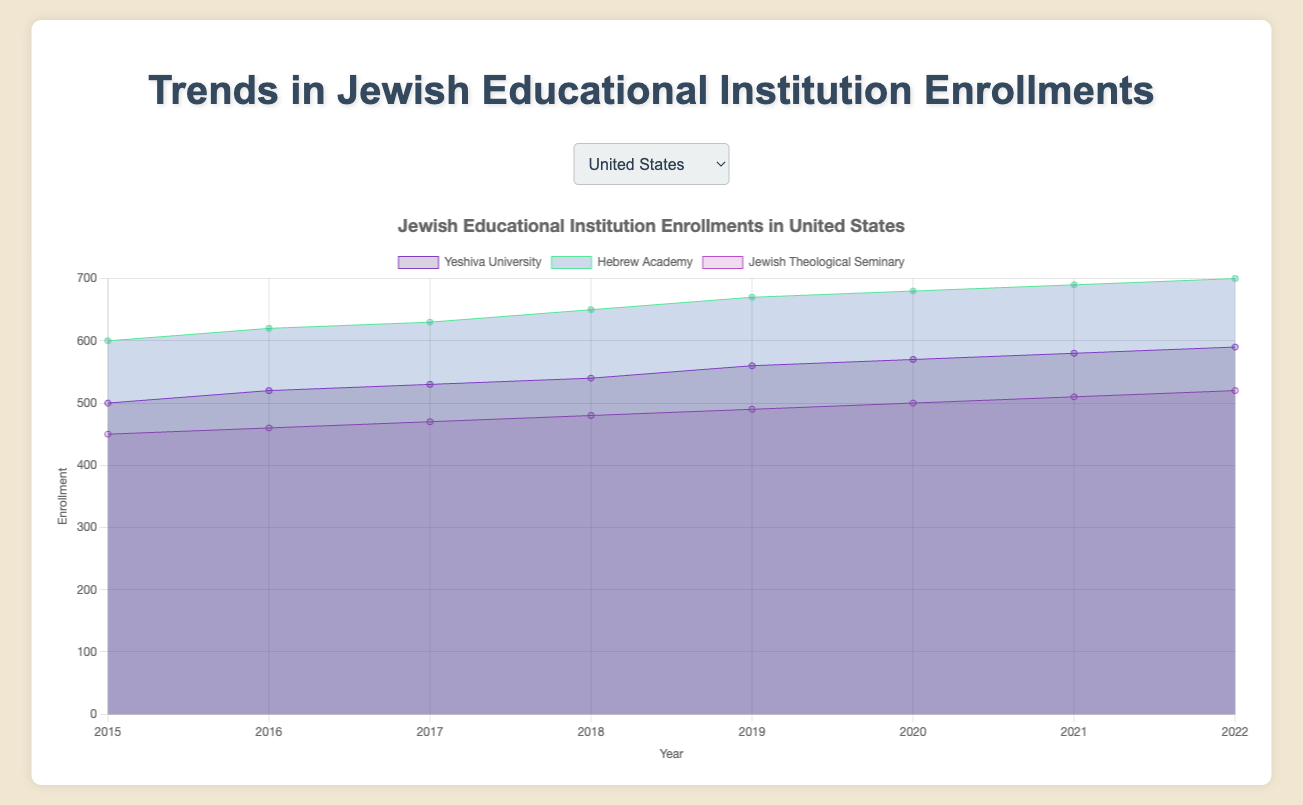Which country has the highest enrollment in 2022 for any single institution? In Israel, Hebrew University of Jerusalem had the highest enrollment in 2022 with 780 students, as shown by the peak on the chart.
Answer: Israel Which institution in the United States had the lowest enrollment in 2015? The Jewish Theological Seminary had the lowest enrollment in 2015 in the United States, with 450 students, according to the chart data.
Answer: Jewish Theological Seminary Compare the enrollment trends for Yeshiva University and Hebrew University of Jerusalem from 2015 to 2022. Which one grew faster? Yeshiva University grew from 500 to 590 (an increase of 90 students), while Hebrew University of Jerusalem increased from 700 to 780 (an increase of 80 students). Thus, Yeshiva University grew faster.
Answer: Yeshiva University What was the total enrollment for Hebrew schools in Canada in the year 2020? Adding the enrollments for TanenbaumCHAT (330), Associated Hebrew Schools (340), and Leo Baeck Day School (290) in 2020 gives a total of 960 students.
Answer: 960 Which institution showed the most consistent increase in enrollments in Australia? Mount Scopus Memorial College showed a consistent increase in enrollments every year from 330 in 2015 to 400 in 2022.
Answer: Mount Scopus Memorial College What is the difference in enrollment between the highest and lowest institutions in the United Kingdom in 2022? Jewish Free School had 420 enrollments and Yavneh College had 220 enrollments in 2022. The difference is 200 students.
Answer: 200 How did enrollments for Bar-Ilan University in Israel change from 2015 to 2020? Enrollment at Bar-Ilan University increased from 400 in 2015 to 450 in 2020, indicating a growth of 50 students.
Answer: Increased by 50 What is the trend for enrollments at the Jewish Theological Seminary in the United States? The Jewish Theological Seminary in the United States shows a gradual increase in enrollments from 450 in 2015 to 520 in 2022.
Answer: Gradual increase Which institution in the United Kingdom grew by the largest absolute number of students from 2015 to 2022? Jewish Free School in the United Kingdom grew from 350 in 2015 to 420 in 2022, an increase of 70 students, the largest absolute growth among the institutions listed.
Answer: Jewish Free School Between Moriah College and Masada College in Australia, which had a higher growth rate from 2018 to 2020? Moriah College grew from 300 in 2018 to 320 in 2020, a 6.67% increase, while Masada College grew from 210 to 230, a 9.52% increase. Therefore, Masada College had a higher growth rate.
Answer: Masada College 